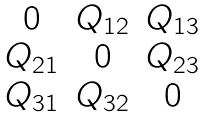Convert formula to latex. <formula><loc_0><loc_0><loc_500><loc_500>\begin{matrix} 0 & Q _ { 1 2 } & Q _ { 1 3 } \\ Q _ { 2 1 } & 0 & Q _ { 2 3 } \\ Q _ { 3 1 } & Q _ { 3 2 } & 0 \end{matrix}</formula> 